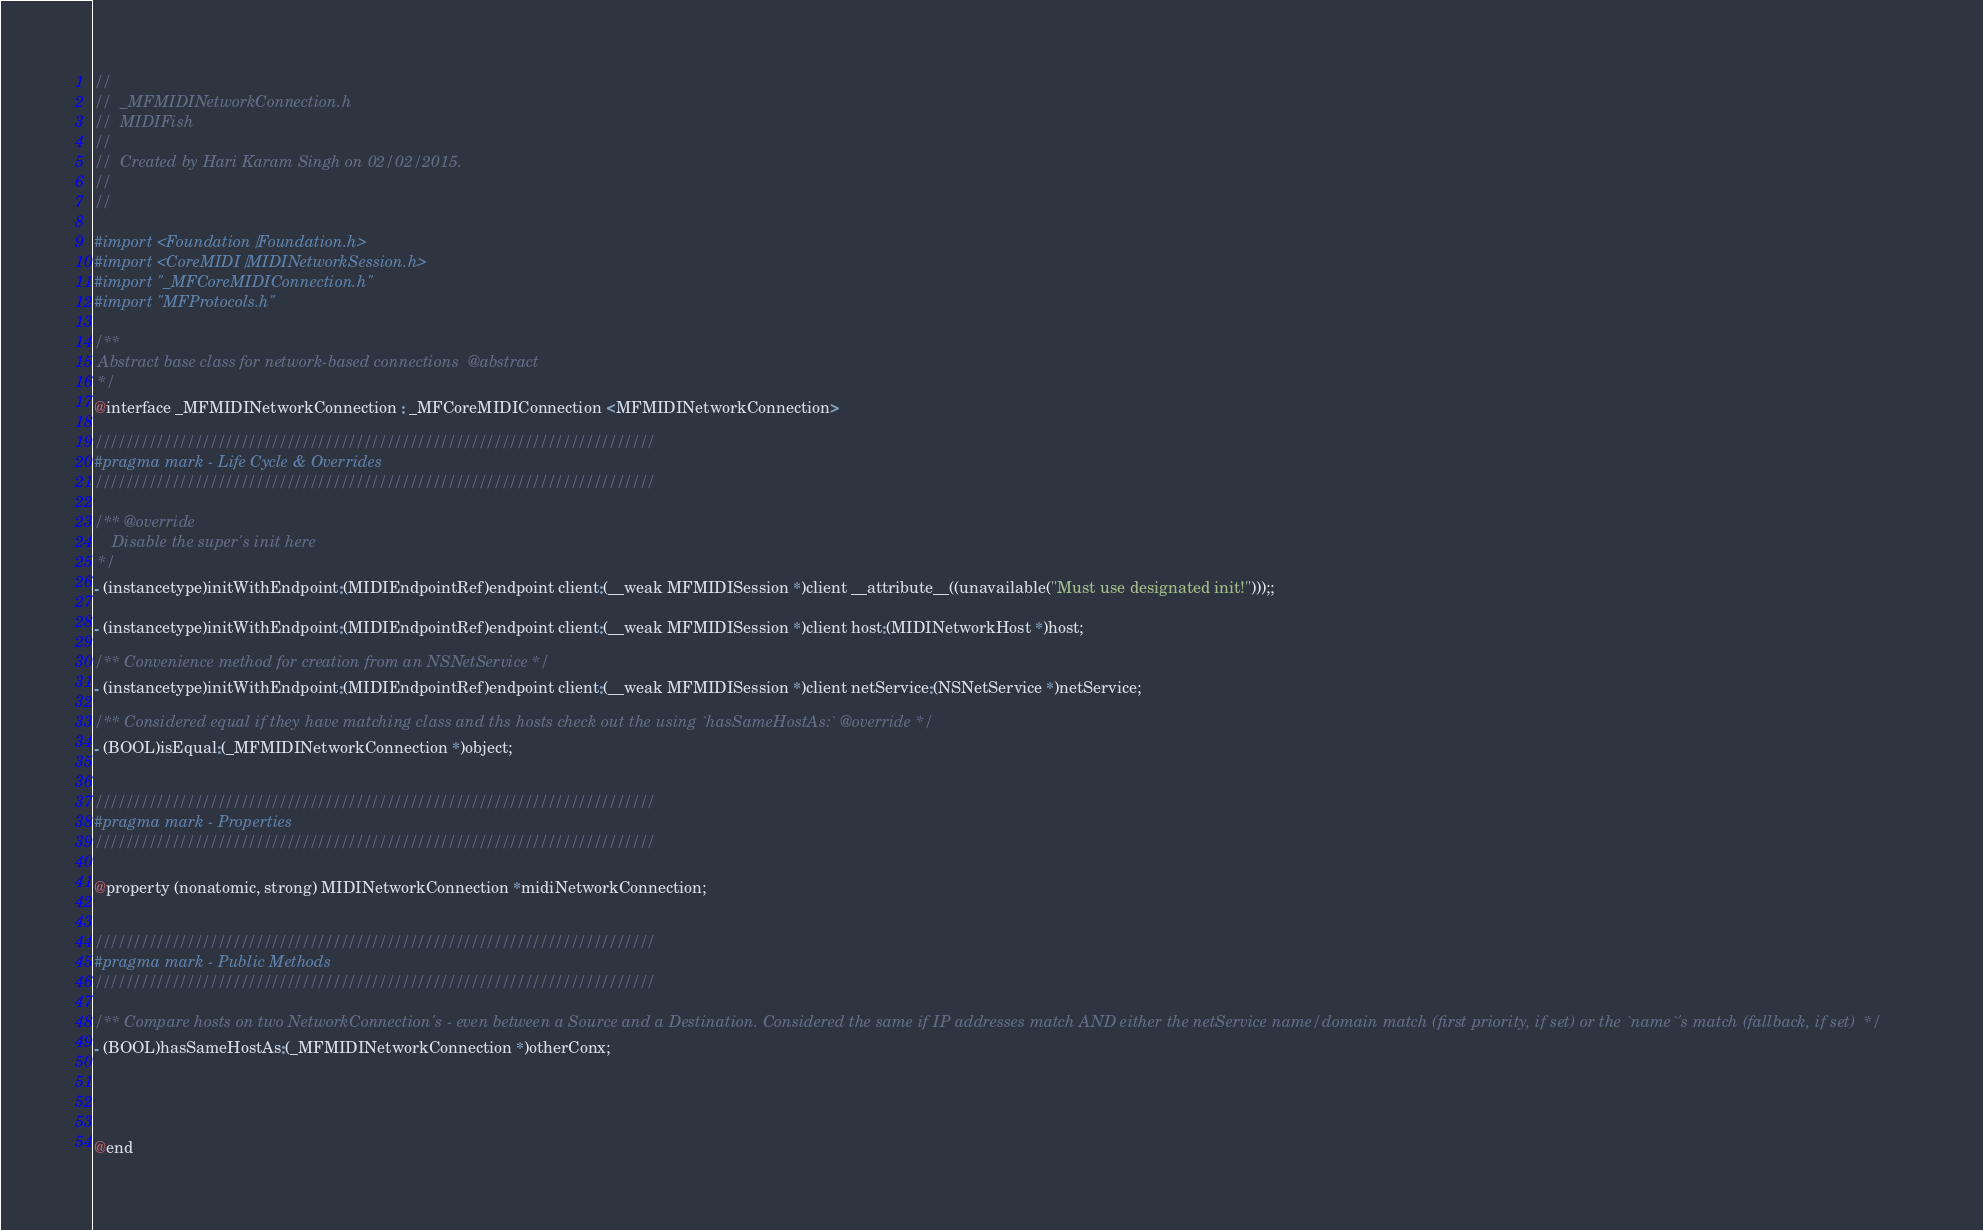Convert code to text. <code><loc_0><loc_0><loc_500><loc_500><_C_>//
//  _MFMIDINetworkConnection.h
//  MIDIFish
//
//  Created by Hari Karam Singh on 02/02/2015.
//
//

#import <Foundation/Foundation.h>
#import <CoreMIDI/MIDINetworkSession.h>
#import "_MFCoreMIDIConnection.h"
#import "MFProtocols.h"

/** 
 Abstract base class for network-based connections  @abstract 
 */
@interface _MFMIDINetworkConnection : _MFCoreMIDIConnection <MFMIDINetworkConnection>

/////////////////////////////////////////////////////////////////////////
#pragma mark - Life Cycle & Overrides
/////////////////////////////////////////////////////////////////////////

/** @override 
    Disable the super's init here 
 */
- (instancetype)initWithEndpoint:(MIDIEndpointRef)endpoint client:(__weak MFMIDISession *)client __attribute__((unavailable("Must use designated init!")));;

- (instancetype)initWithEndpoint:(MIDIEndpointRef)endpoint client:(__weak MFMIDISession *)client host:(MIDINetworkHost *)host;

/** Convenience method for creation from an NSNetService */
- (instancetype)initWithEndpoint:(MIDIEndpointRef)endpoint client:(__weak MFMIDISession *)client netService:(NSNetService *)netService;

/** Considered equal if they have matching class and ths hosts check out the using `hasSameHostAs:` @override */
- (BOOL)isEqual:(_MFMIDINetworkConnection *)object;


/////////////////////////////////////////////////////////////////////////
#pragma mark - Properties
/////////////////////////////////////////////////////////////////////////

@property (nonatomic, strong) MIDINetworkConnection *midiNetworkConnection;


/////////////////////////////////////////////////////////////////////////
#pragma mark - Public Methods
/////////////////////////////////////////////////////////////////////////

/** Compare hosts on two NetworkConnection's - even between a Source and a Destination. Considered the same if IP addresses match AND either the netService name/domain match (first priority, if set) or the `name`'s match (fallback, if set)  */
- (BOOL)hasSameHostAs:(_MFMIDINetworkConnection *)otherConx;




@end
</code> 